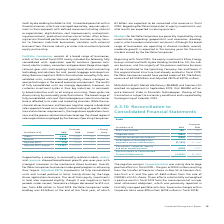According to Siemens Ag's financial document, What caused the negative swing in corporate items? Based on the financial document, the answer is The negative swing in Corporate items was mainly due to large positive effects in fiscal 2018 – the gain of € 900 million resulting from the transfer of Siemens’ shares in Atos SE to Siemens Pension- Trust e. V. and the gain of € 655 million from the sale of OSRAM Licht AG shares.. Also, What were the severance charges within Corporate items? According to the financial document, 99 (in millions). The relevant text states: ". Severance charges within Corporate items were € 99 million (€ 159 million in fiscal 2018)...." Also, What was the Reconciliation to Consolidated financial Statements in 2019? According to the financial document, (2,028) (in millions). The relevant text states: "econciliation to Consolidated Financial Statements (2,028) (1,135)..." Also, can you calculate: What was the average Real Estate Services? To answer this question, I need to perform calculations using the financial data. The calculation is: (145 + 140) / 2, which equals 142.5 (in millions). This is based on the information: "Real Estate Services 145 140 Real Estate Services 145 140..." The key data points involved are: 140, 145. Also, can you calculate: What is the increase / (decrease) in Amortization of intangible assets acquired in business combinations from 2018 to 2019? Based on the calculation: 1,133 - 1,164, the result is -31 (in millions). This is based on the information: "angible assets acquired in business combinations (1,133) (1,164) assets acquired in business combinations (1,133) (1,164)..." The key data points involved are: 1,133, 1,164. Also, can you calculate: What is the increase / (decrease) percentage of Centrally carried pension expense from 2018 to 2019? To answer this question, I need to perform calculations using the financial data. The calculation is: (264 / 423 - 1), which equals -37.59 (percentage). This is based on the information: "Centrally carried pension expense (264) (423) Centrally carried pension expense (264) (423)..." The key data points involved are: 264, 423. 